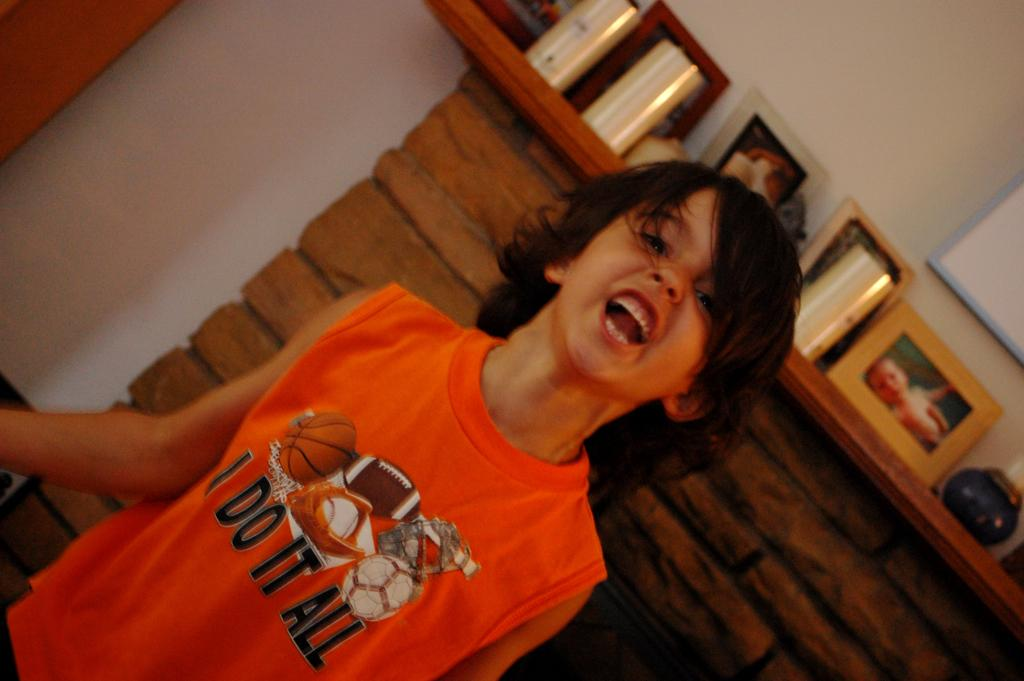<image>
Offer a succinct explanation of the picture presented. an ugly kid with a tshirt that says i do it all 